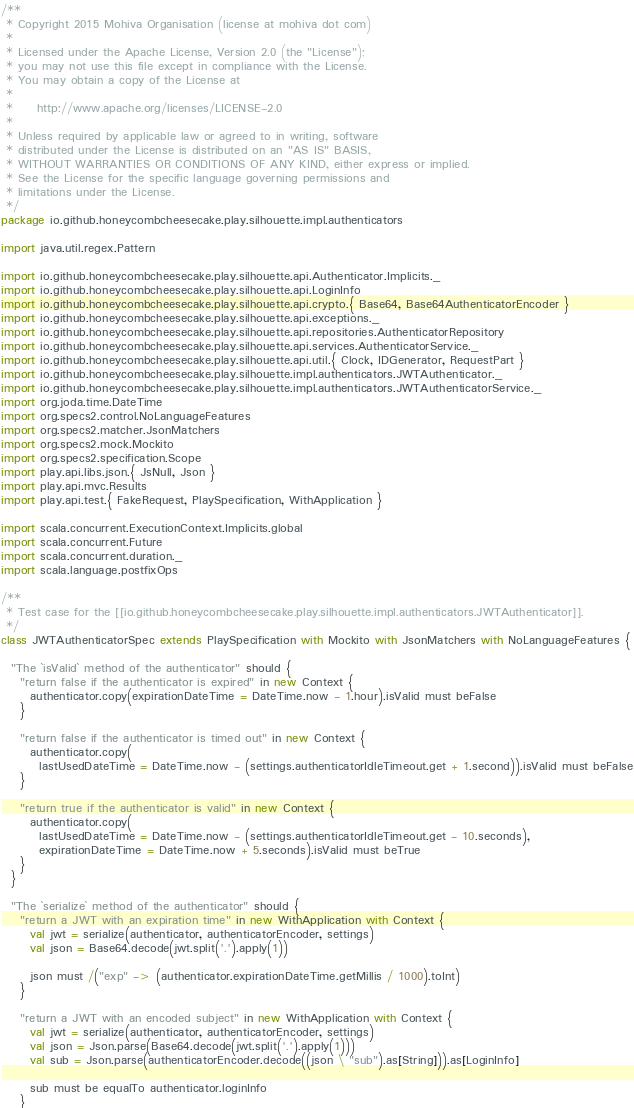Convert code to text. <code><loc_0><loc_0><loc_500><loc_500><_Scala_>/**
 * Copyright 2015 Mohiva Organisation (license at mohiva dot com)
 *
 * Licensed under the Apache License, Version 2.0 (the "License");
 * you may not use this file except in compliance with the License.
 * You may obtain a copy of the License at
 *
 *     http://www.apache.org/licenses/LICENSE-2.0
 *
 * Unless required by applicable law or agreed to in writing, software
 * distributed under the License is distributed on an "AS IS" BASIS,
 * WITHOUT WARRANTIES OR CONDITIONS OF ANY KIND, either express or implied.
 * See the License for the specific language governing permissions and
 * limitations under the License.
 */
package io.github.honeycombcheesecake.play.silhouette.impl.authenticators

import java.util.regex.Pattern

import io.github.honeycombcheesecake.play.silhouette.api.Authenticator.Implicits._
import io.github.honeycombcheesecake.play.silhouette.api.LoginInfo
import io.github.honeycombcheesecake.play.silhouette.api.crypto.{ Base64, Base64AuthenticatorEncoder }
import io.github.honeycombcheesecake.play.silhouette.api.exceptions._
import io.github.honeycombcheesecake.play.silhouette.api.repositories.AuthenticatorRepository
import io.github.honeycombcheesecake.play.silhouette.api.services.AuthenticatorService._
import io.github.honeycombcheesecake.play.silhouette.api.util.{ Clock, IDGenerator, RequestPart }
import io.github.honeycombcheesecake.play.silhouette.impl.authenticators.JWTAuthenticator._
import io.github.honeycombcheesecake.play.silhouette.impl.authenticators.JWTAuthenticatorService._
import org.joda.time.DateTime
import org.specs2.control.NoLanguageFeatures
import org.specs2.matcher.JsonMatchers
import org.specs2.mock.Mockito
import org.specs2.specification.Scope
import play.api.libs.json.{ JsNull, Json }
import play.api.mvc.Results
import play.api.test.{ FakeRequest, PlaySpecification, WithApplication }

import scala.concurrent.ExecutionContext.Implicits.global
import scala.concurrent.Future
import scala.concurrent.duration._
import scala.language.postfixOps

/**
 * Test case for the [[io.github.honeycombcheesecake.play.silhouette.impl.authenticators.JWTAuthenticator]].
 */
class JWTAuthenticatorSpec extends PlaySpecification with Mockito with JsonMatchers with NoLanguageFeatures {

  "The `isValid` method of the authenticator" should {
    "return false if the authenticator is expired" in new Context {
      authenticator.copy(expirationDateTime = DateTime.now - 1.hour).isValid must beFalse
    }

    "return false if the authenticator is timed out" in new Context {
      authenticator.copy(
        lastUsedDateTime = DateTime.now - (settings.authenticatorIdleTimeout.get + 1.second)).isValid must beFalse
    }

    "return true if the authenticator is valid" in new Context {
      authenticator.copy(
        lastUsedDateTime = DateTime.now - (settings.authenticatorIdleTimeout.get - 10.seconds),
        expirationDateTime = DateTime.now + 5.seconds).isValid must beTrue
    }
  }

  "The `serialize` method of the authenticator" should {
    "return a JWT with an expiration time" in new WithApplication with Context {
      val jwt = serialize(authenticator, authenticatorEncoder, settings)
      val json = Base64.decode(jwt.split('.').apply(1))

      json must /("exp" -> (authenticator.expirationDateTime.getMillis / 1000).toInt)
    }

    "return a JWT with an encoded subject" in new WithApplication with Context {
      val jwt = serialize(authenticator, authenticatorEncoder, settings)
      val json = Json.parse(Base64.decode(jwt.split('.').apply(1)))
      val sub = Json.parse(authenticatorEncoder.decode((json \ "sub").as[String])).as[LoginInfo]

      sub must be equalTo authenticator.loginInfo
    }
</code> 